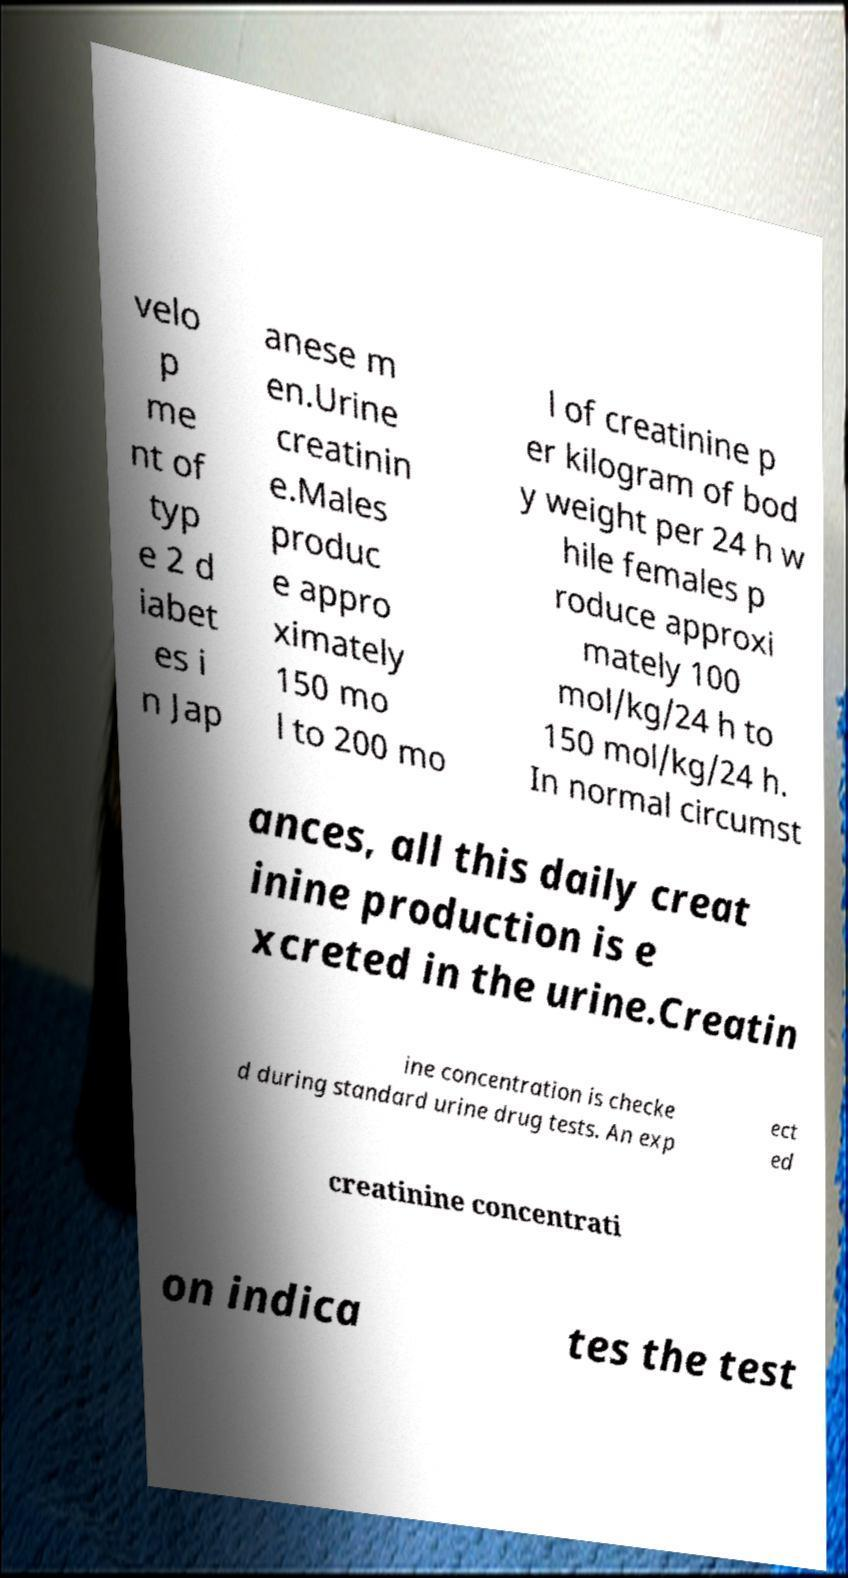Could you assist in decoding the text presented in this image and type it out clearly? velo p me nt of typ e 2 d iabet es i n Jap anese m en.Urine creatinin e.Males produc e appro ximately 150 mo l to 200 mo l of creatinine p er kilogram of bod y weight per 24 h w hile females p roduce approxi mately 100 mol/kg/24 h to 150 mol/kg/24 h. In normal circumst ances, all this daily creat inine production is e xcreted in the urine.Creatin ine concentration is checke d during standard urine drug tests. An exp ect ed creatinine concentrati on indica tes the test 